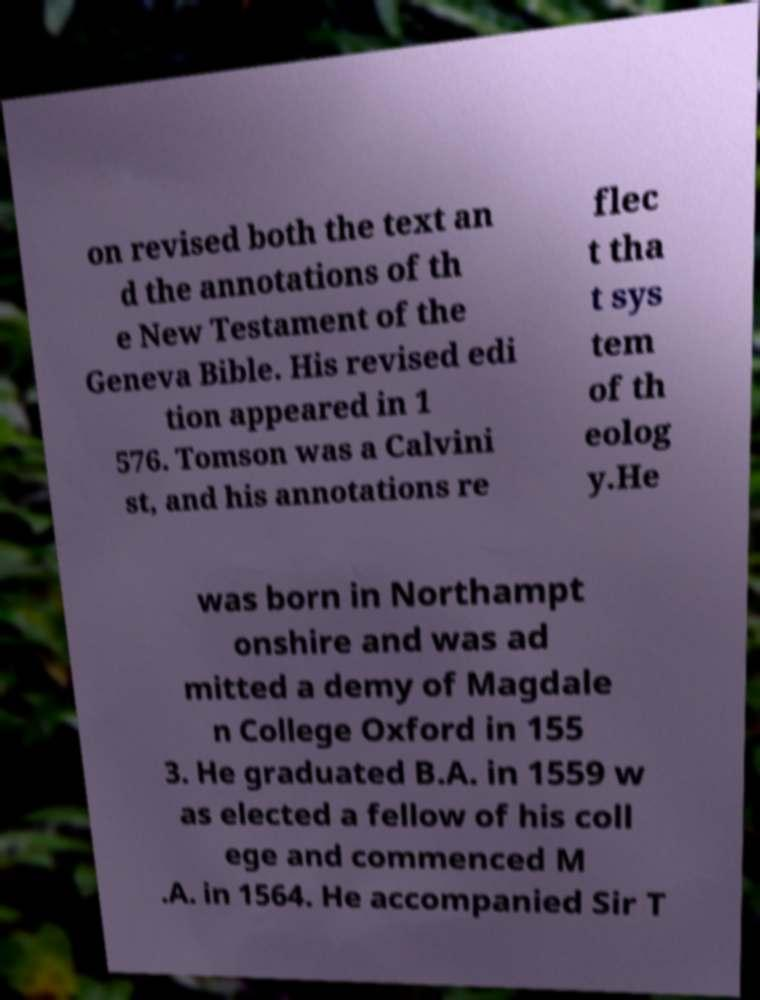Could you assist in decoding the text presented in this image and type it out clearly? on revised both the text an d the annotations of th e New Testament of the Geneva Bible. His revised edi tion appeared in 1 576. Tomson was a Calvini st, and his annotations re flec t tha t sys tem of th eolog y.He was born in Northampt onshire and was ad mitted a demy of Magdale n College Oxford in 155 3. He graduated B.A. in 1559 w as elected a fellow of his coll ege and commenced M .A. in 1564. He accompanied Sir T 